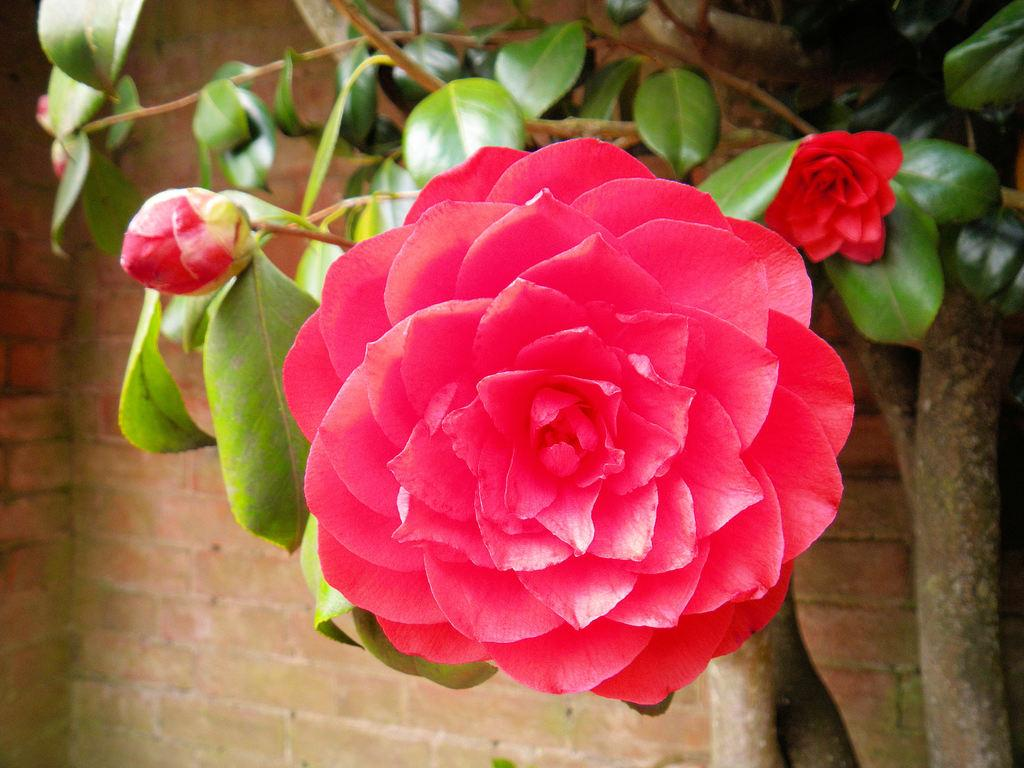What type of plant is in the image? There is a plant in the image, and it has flowers and buds. What can be seen on the plant besides the leaves? The plant has flowers and buds. What is visible in the background of the image? There is a wall visible in the image. What type of experience can be seen on the plant in the image? There is no experience present on the plant in the image; it is a living organism with flowers and buds. How many ants are visible on the plant in the image? There are no ants present on the plant in the image. 